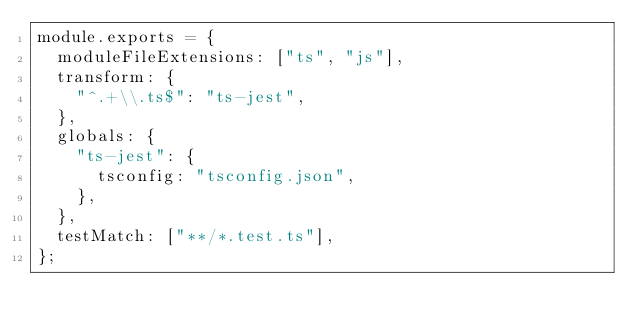<code> <loc_0><loc_0><loc_500><loc_500><_JavaScript_>module.exports = {
  moduleFileExtensions: ["ts", "js"],
  transform: {
    "^.+\\.ts$": "ts-jest",
  },
  globals: {
    "ts-jest": {
      tsconfig: "tsconfig.json",
    },
  },
  testMatch: ["**/*.test.ts"],
};</code> 